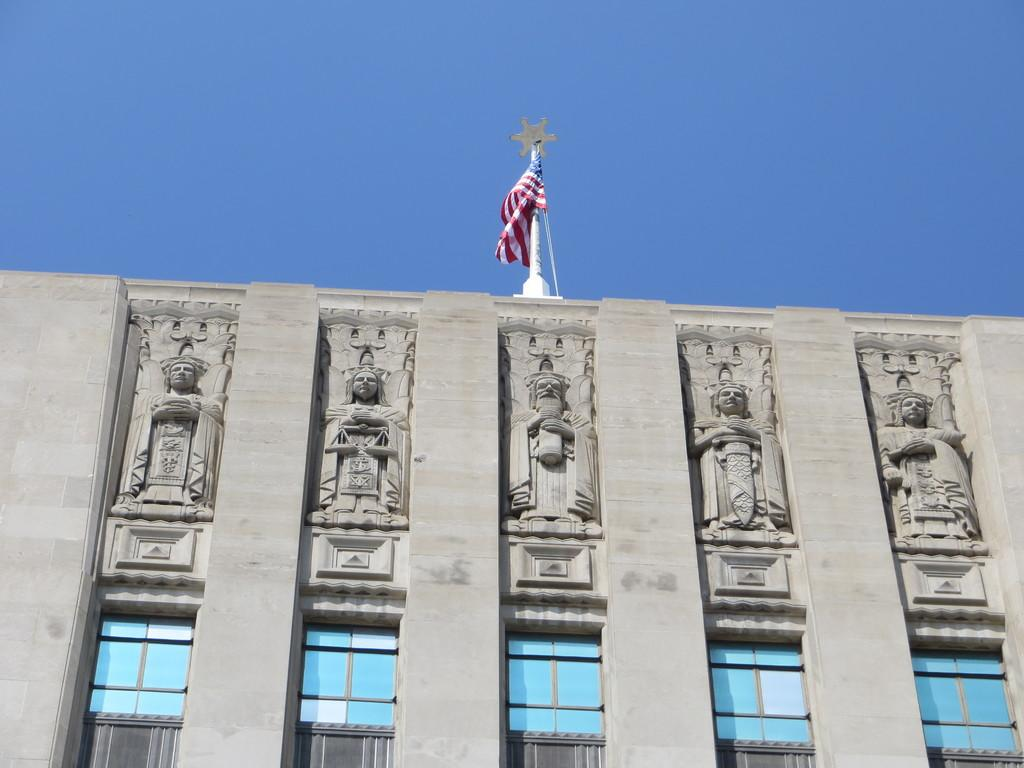What type of structure is in the image? There is a building in the image. What features can be seen on the building? The building has statues and windows. What is at the top of the building? There is a flag at the top of the building. What can be seen in the background of the image? The sky is visible in the background of the image. What type of texture can be seen on the donkey in the image? There is no donkey present in the image. How many wounds are visible on the building in the image? There are no wounds visible on the building in the image. 